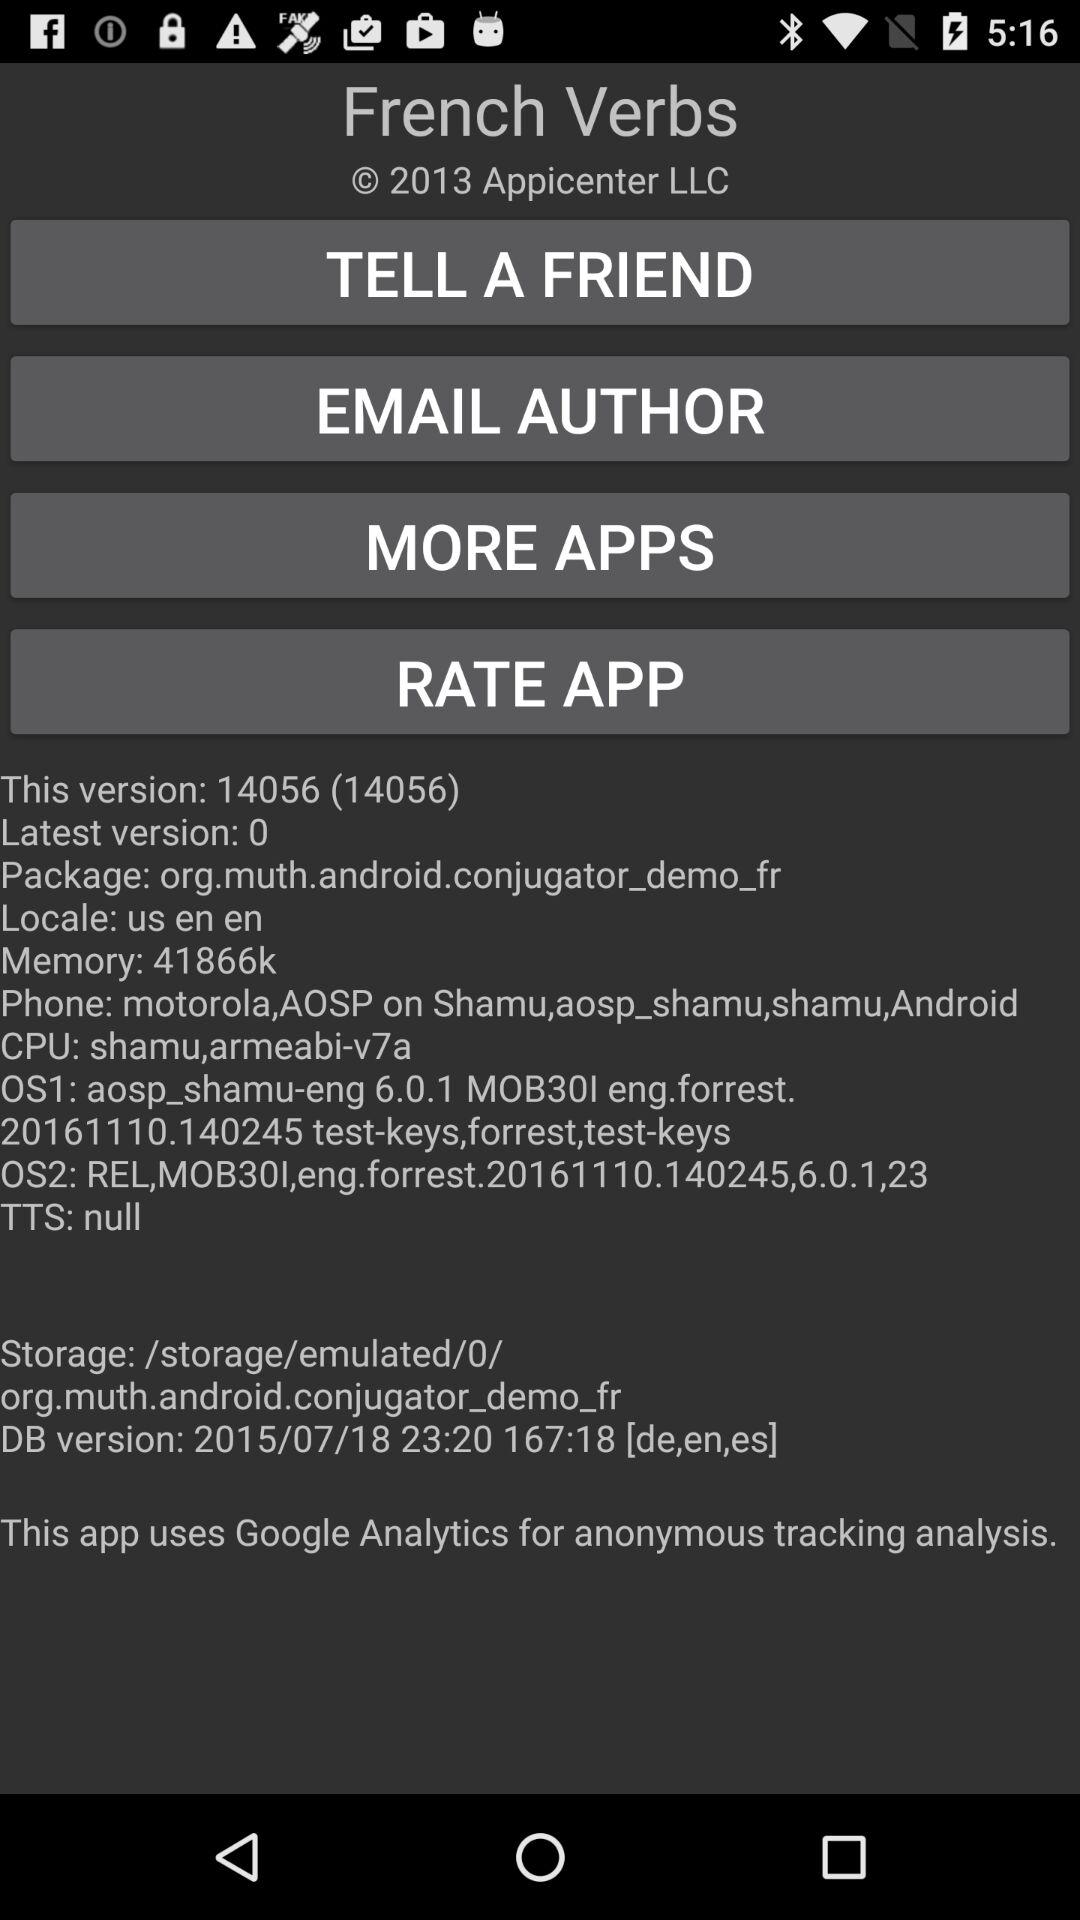What's the storage path? The storage path is "/storage/emulated/0/org.muth.android.conjugator_demo_fr". 